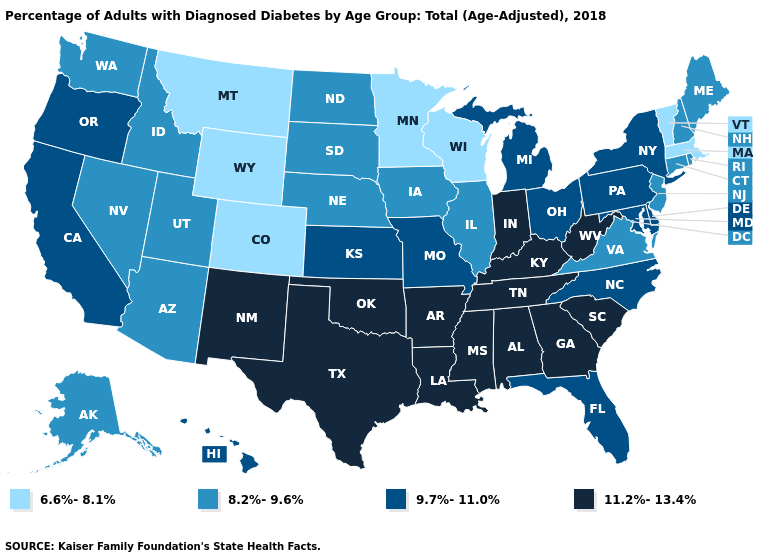What is the value of South Carolina?
Write a very short answer. 11.2%-13.4%. Name the states that have a value in the range 8.2%-9.6%?
Short answer required. Alaska, Arizona, Connecticut, Idaho, Illinois, Iowa, Maine, Nebraska, Nevada, New Hampshire, New Jersey, North Dakota, Rhode Island, South Dakota, Utah, Virginia, Washington. Is the legend a continuous bar?
Answer briefly. No. Among the states that border Vermont , does New Hampshire have the lowest value?
Give a very brief answer. No. Does North Dakota have the lowest value in the MidWest?
Give a very brief answer. No. Which states have the lowest value in the MidWest?
Write a very short answer. Minnesota, Wisconsin. Which states have the lowest value in the Northeast?
Give a very brief answer. Massachusetts, Vermont. What is the highest value in states that border Nevada?
Be succinct. 9.7%-11.0%. Name the states that have a value in the range 8.2%-9.6%?
Be succinct. Alaska, Arizona, Connecticut, Idaho, Illinois, Iowa, Maine, Nebraska, Nevada, New Hampshire, New Jersey, North Dakota, Rhode Island, South Dakota, Utah, Virginia, Washington. What is the lowest value in the West?
Keep it brief. 6.6%-8.1%. What is the value of Minnesota?
Short answer required. 6.6%-8.1%. What is the value of Wisconsin?
Short answer required. 6.6%-8.1%. Name the states that have a value in the range 6.6%-8.1%?
Concise answer only. Colorado, Massachusetts, Minnesota, Montana, Vermont, Wisconsin, Wyoming. What is the highest value in the MidWest ?
Answer briefly. 11.2%-13.4%. Does Nebraska have a lower value than New Hampshire?
Quick response, please. No. 